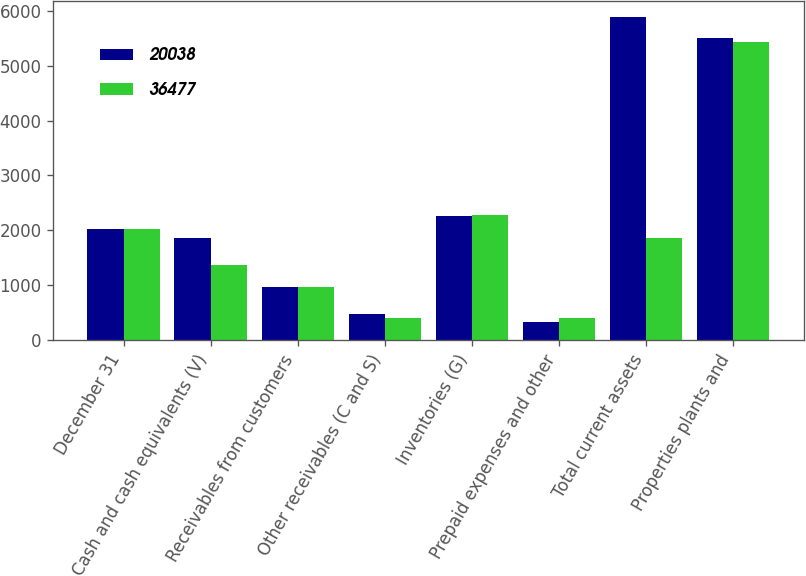<chart> <loc_0><loc_0><loc_500><loc_500><stacked_bar_chart><ecel><fcel>December 31<fcel>Cash and cash equivalents (V)<fcel>Receivables from customers<fcel>Other receivables (C and S)<fcel>Inventories (G)<fcel>Prepaid expenses and other<fcel>Total current assets<fcel>Properties plants and<nl><fcel>20038<fcel>2016<fcel>1863<fcel>974<fcel>477<fcel>2253<fcel>325<fcel>5892<fcel>5499<nl><fcel>36477<fcel>2015<fcel>1362<fcel>960<fcel>394<fcel>2284<fcel>397<fcel>1863<fcel>5425<nl></chart> 